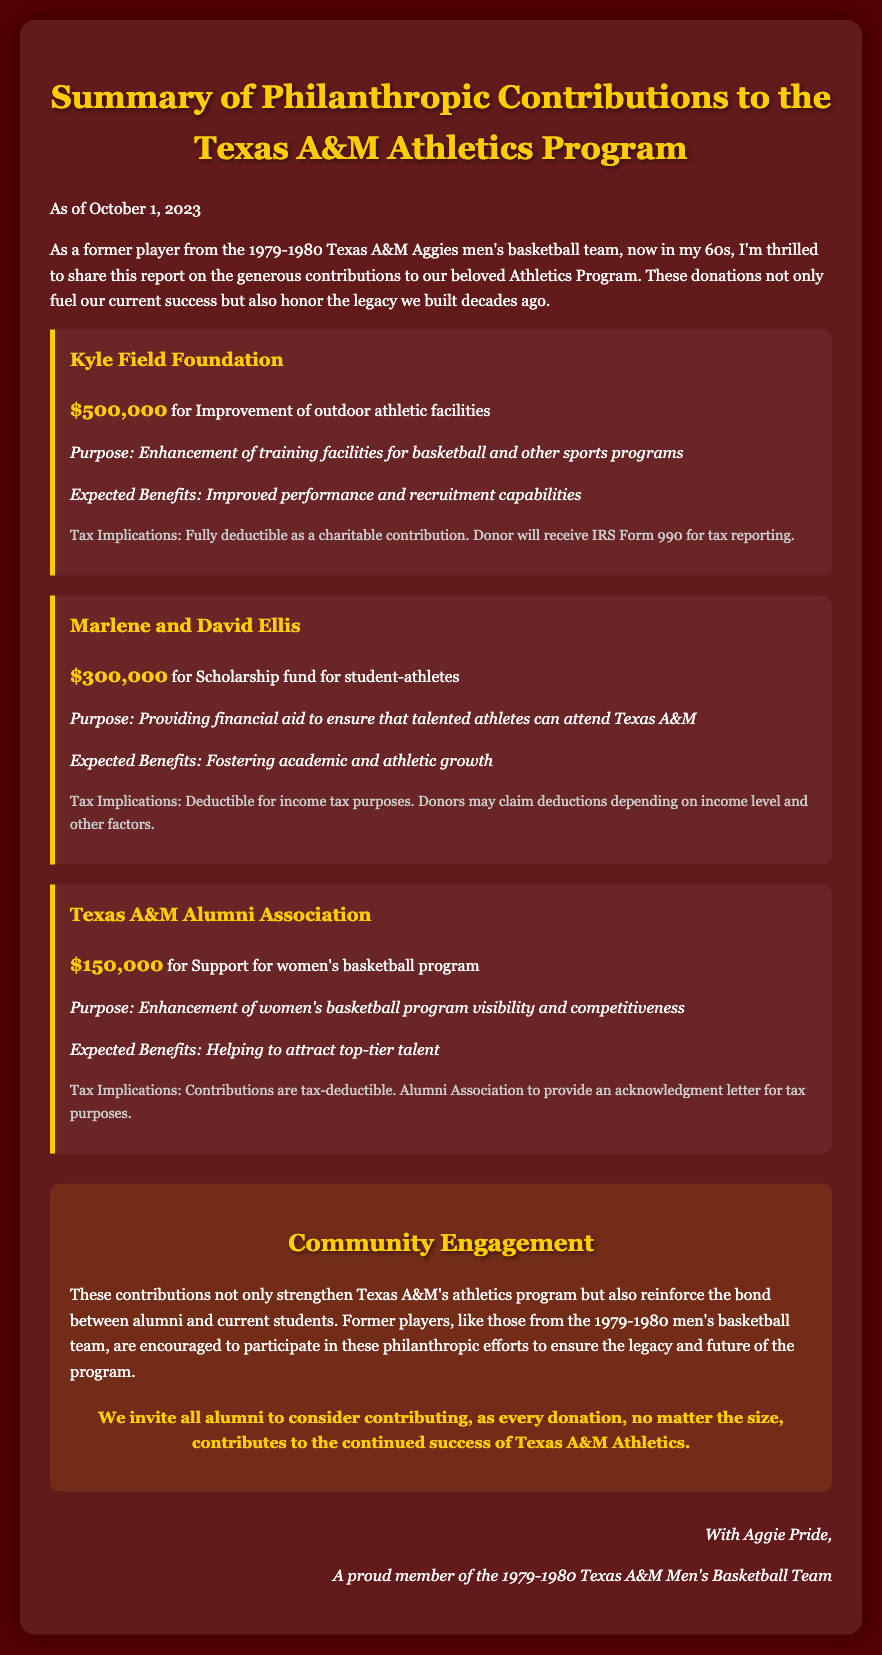What is the total amount of donations listed in the report? The total amount of donations is calculated by adding the contributions from each donor: $500,000 + $300,000 + $150,000 = $950,000.
Answer: $950,000 Who is the contributor for the scholarship fund? The document states that Marlene and David Ellis provided the donation for the scholarship fund for student-athletes.
Answer: Marlene and David Ellis What is the purpose of the Kyle Field Foundation's donation? The purpose outlined in the document for the Kyle Field Foundation's donation is the enhancement of training facilities for basketball and other sports programs.
Answer: Enhancement of training facilities for basketball and other sports programs What is the expected benefit of the Texas A&M Alumni Association's contribution? The expected benefit of the Texas A&M Alumni Association's contribution is helping to attract top-tier talent for the women's basketball program.
Answer: Helping to attract top-tier talent What are the tax implications of the donation from the Texas A&M Alumni Association? The tax implications for the contribution from the Texas A&M Alumni Association state that contributions are tax-deductible and that an acknowledgment letter will be provided for tax purposes.
Answer: Contributions are tax-deductible What is the specific amount donated by the Kyle Field Foundation? According to the document, the Kyle Field Foundation donated a specific amount listed as $500,000 for improvements.
Answer: $500,000 What is the significance of community engagement mentioned in the report? The report highlights that community engagement strengthens the athletics program and reinforces bonds between alumni and current students, encouraging participation in philanthropic efforts.
Answer: Strengthens Texas A&M's athletics program What does the report suggest former players do? The report suggests that former players, like those from the 1979-1980 men's basketball team, are encouraged to participate in philanthropic efforts to contribute to the program's legacy and future.
Answer: Participate in philanthropic efforts 